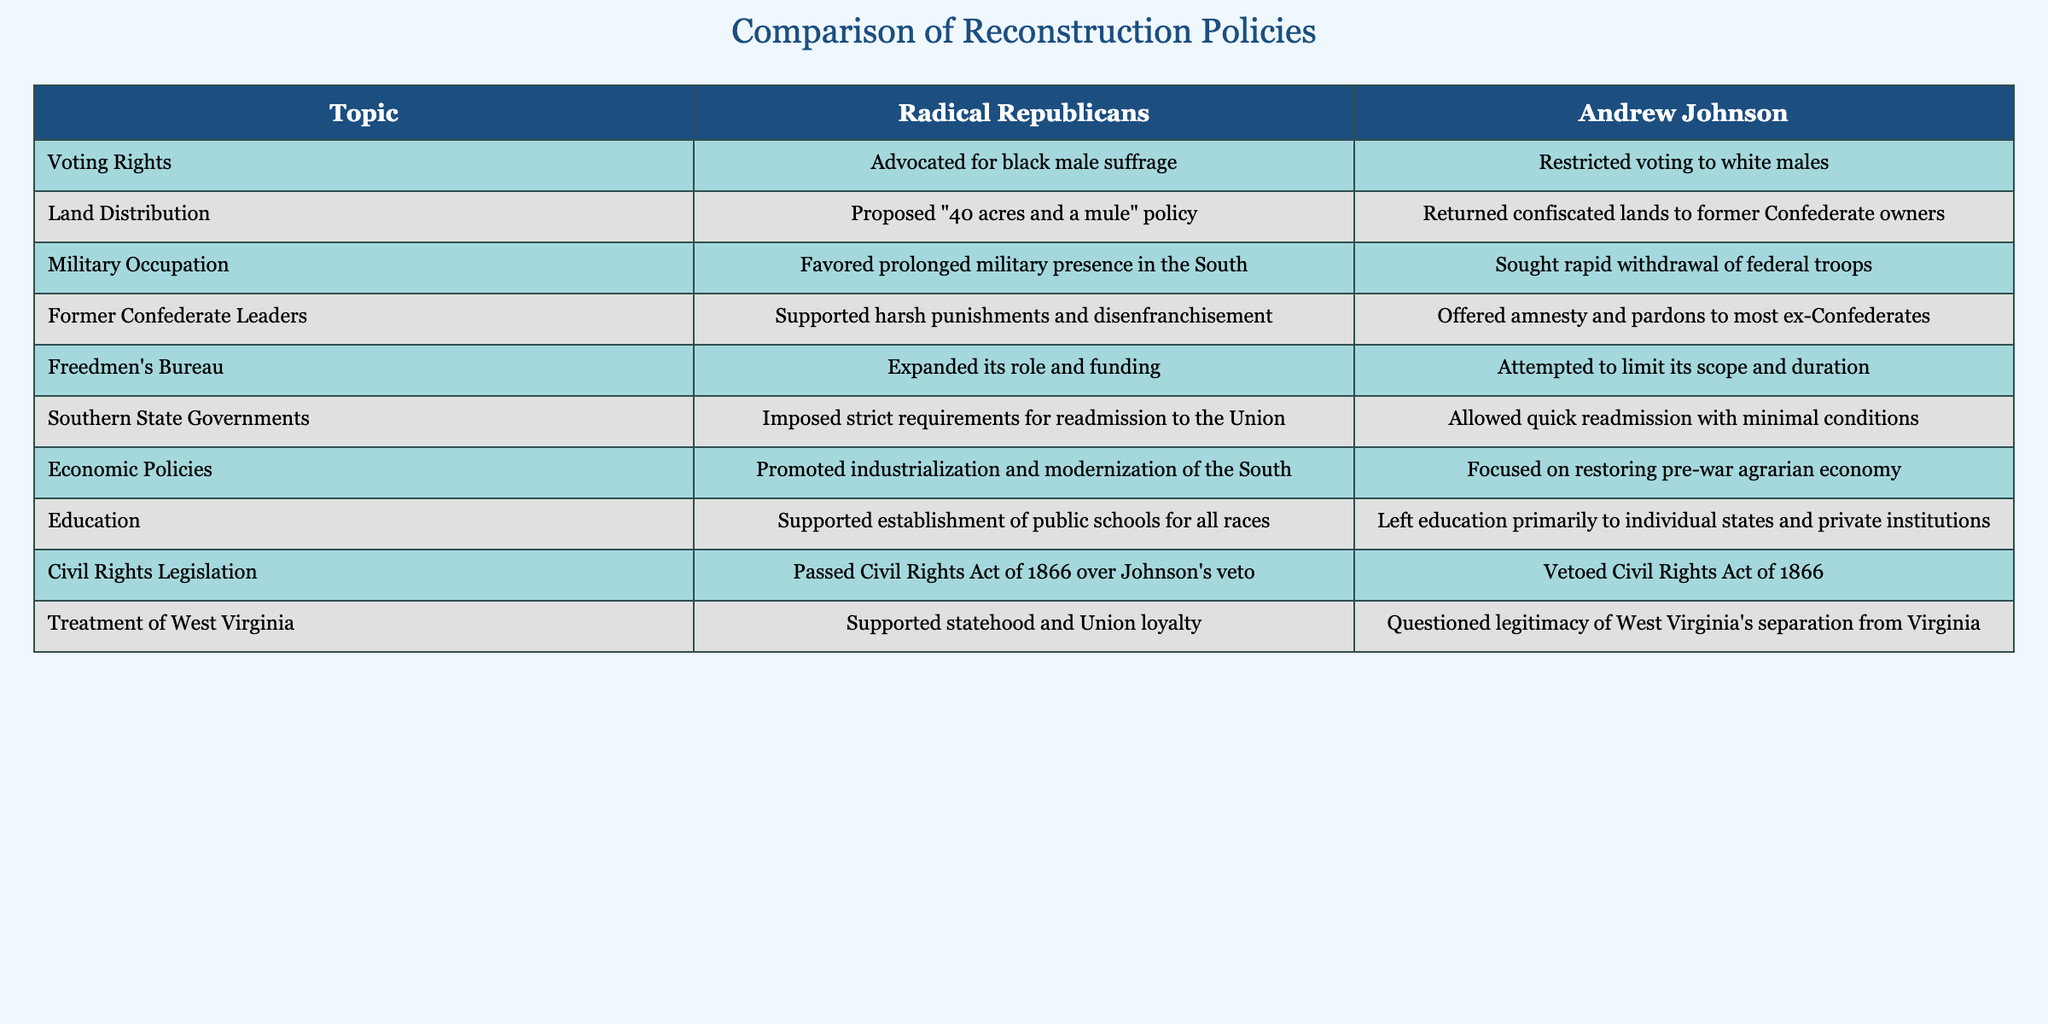What voting rights did the Radical Republicans advocate for? According to the table, the Radical Republicans advocated for black male suffrage, which means they supported the right to vote for Black men.
Answer: Advocated for black male suffrage How did Andrew Johnson's approach to the Freedmen's Bureau differ from the Radical Republicans? The table shows that the Radical Republicans expanded the role and funding of the Freedmen's Bureau, while Andrew Johnson attempted to limit its scope and duration.
Answer: Expanded its role and funding vs. Attempted to limit its scope and duration Did Andrew Johnson support the Civil Rights Act of 1866? The table indicates that Andrew Johnson vetoed the Civil Rights Act of 1866, meaning he did not support it.
Answer: No What were the contrasting views on land distribution between the Radical Republicans and Andrew Johnson? According to the table, the Radical Republicans proposed a "40 acres and a mule" policy for land distribution, whereas Andrew Johnson returned confiscated lands to former Confederate owners.
Answer: "40 acres and a mule" policy vs. Returned lands to former owners How many policies regarding Southern state governments were more lenient under Andrew Johnson compared to the Radical Republicans? The table shows that Andrew Johnson allowed for quick readmission with minimal conditions, while the Radical Republicans imposed strict requirements for readmission. This indicates one distinct policy that was more lenient under Johnson.
Answer: One policy What was the focus of the economic policies of the Radical Republicans compared to Andrew Johnson's? The table reveals that the Radical Republicans promoted industrialization and modernization of the South, in contrast to Andrew Johnson, who focused on restoring the pre-war agrarian economy. This highlights a fundamental difference in their economic visions.
Answer: Industrialization and modernization vs. Restoring agrarian economy Did the Radical Republicans and Andrew Johnson agree on the treatment of former Confederate leaders? The table states that Radical Republicans supported harsh punishments and disenfranchisement of former Confederate leaders, while Andrew Johnson offered amnesty and pardons to most ex-Confederates, indicating a clear disagreement.
Answer: No, they disagreed What is the significance of the Radical Republicans' support for public schools compared to Johnson's stance? The Radical Republicans supported the establishment of public schools for all races, whereas Johnson left education primarily to individual states and private institutions. This indicates a commitment to inclusive education by the Radical Republicans that Johnson did not share.
Answer: Supported public schools vs. Left education to states and private institutions In what way did Johnson’s approach question the legitimacy of West Virginia's statehood? The table indicates that Andrew Johnson questioned the legitimacy of West Virginia's separation from Virginia, meaning he did not fully accept the state's status as a separate entity stemming from the Civil War.
Answer: He questioned its legitimacy 